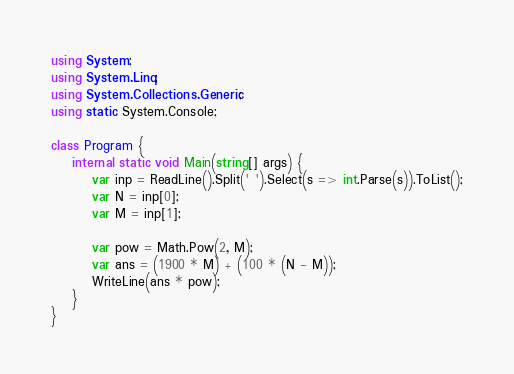<code> <loc_0><loc_0><loc_500><loc_500><_C#_>using System;
using System.Linq;
using System.Collections.Generic;
using static System.Console;

class Program {
    internal static void Main(string[] args) {
        var inp = ReadLine().Split(' ').Select(s => int.Parse(s)).ToList();
        var N = inp[0];
        var M = inp[1];

        var pow = Math.Pow(2, M);
        var ans = (1900 * M) + (100 * (N - M));
        WriteLine(ans * pow);
    }
}</code> 